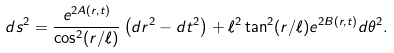<formula> <loc_0><loc_0><loc_500><loc_500>d s ^ { 2 } = \frac { e ^ { 2 A ( r , t ) } } { \cos ^ { 2 } ( r / \ell ) } \left ( d r ^ { 2 } - d t ^ { 2 } \right ) + \ell ^ { 2 } \tan ^ { 2 } ( r / \ell ) e ^ { 2 B ( r , t ) } d \theta ^ { 2 } .</formula> 